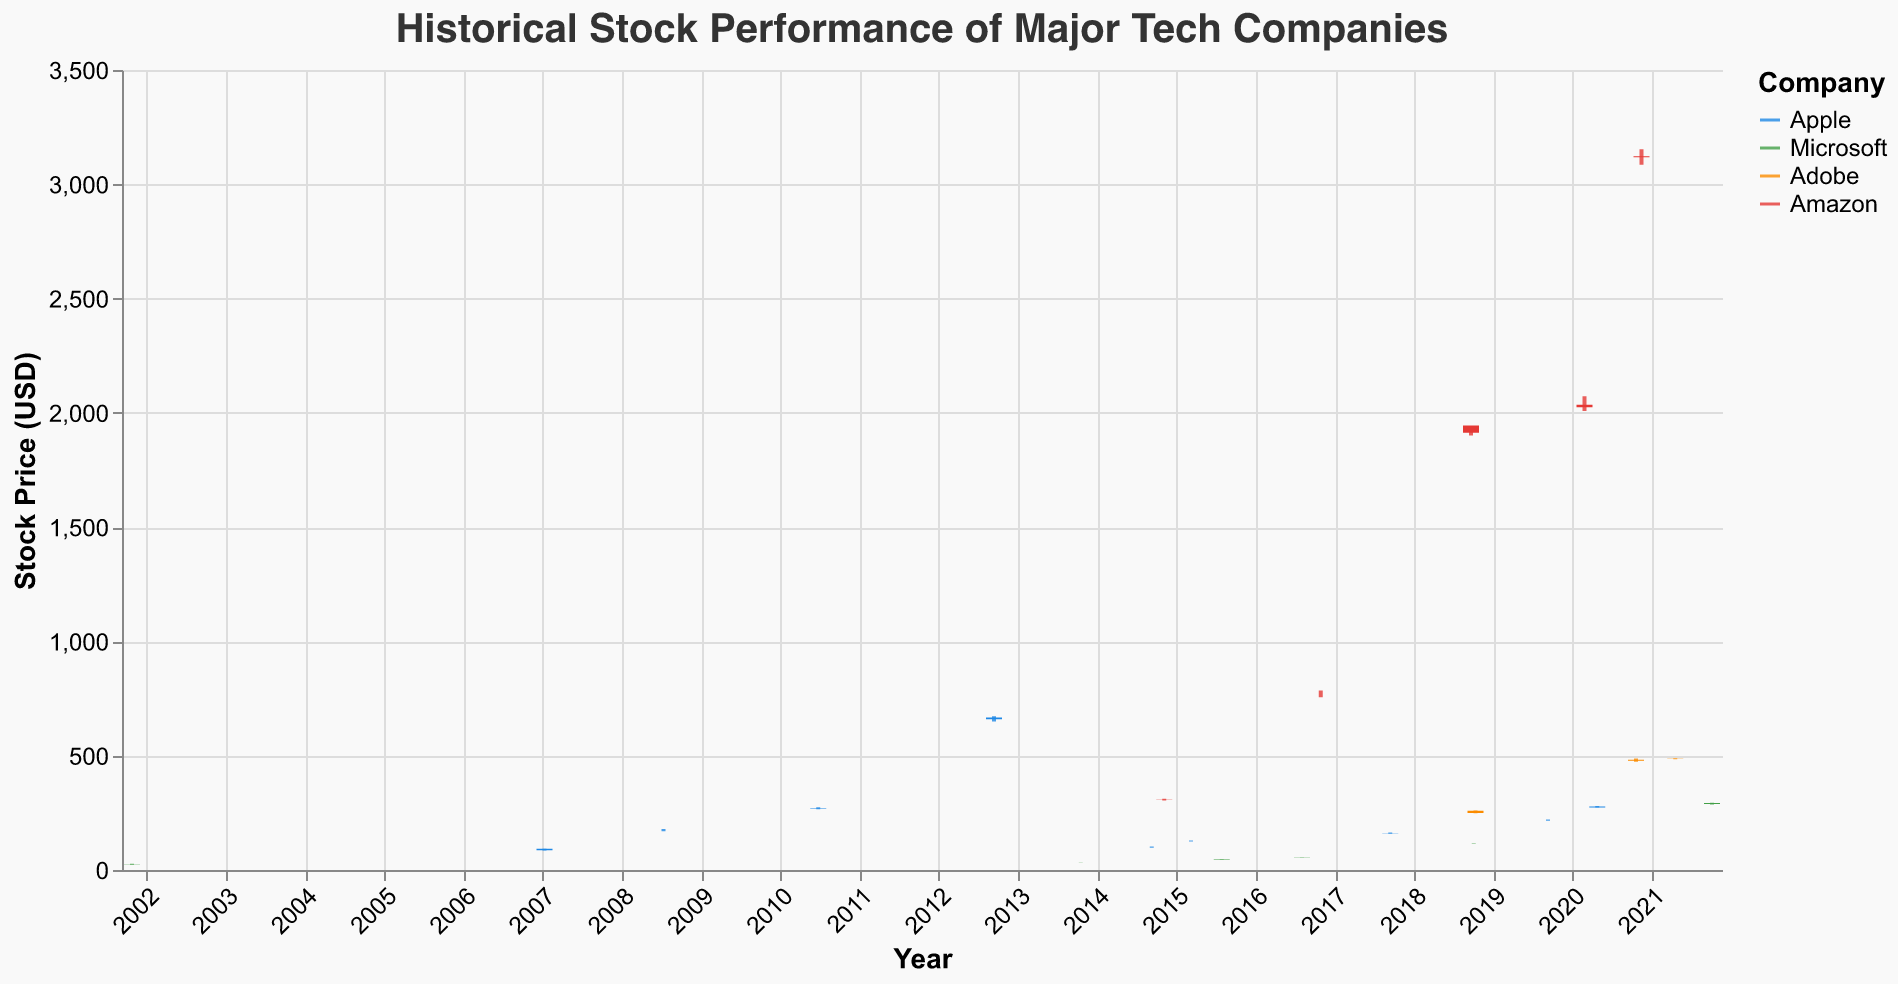How many companies are represented in the figure? The title of the figure and the legend indicate that the plot represents data from four companies: Apple, Microsoft, Adobe, and Amazon.
Answer: 4 What is the stock price range for Apple on 2012-09-12? On 2012-09-12, Apple has a Low value of 650.0 and a High value of 673.0 as visible in the candlestick plot.
Answer: 650.0 - 673.0 Which company had the highest closing price according to the plot? By examining the y-axis values of the closing prices for all companies, Amazon had the highest closing price on 2020-11-14, which was 3118.06.
Answer: Amazon How does the stock price of Microsoft on 2001-10-25 compare to its stock price on 2021-10-05? On 2001-10-25, Microsoft's closing price was 26.49, whereas on 2021-10-05, it was 292.8. The closing price increased significantly over the years.
Answer: Increased Which day had the lowest trading volume for Amazon? By looking at the volume values for Amazon, the lowest trading volume was 5,320,000 on 2018-09-20.
Answer: 2018-09-20 What was the percentage increase in Apple's closing price from 2007-01-09 to 2012-09-12? Apple's closing price on 2007-01-09 was 92.57 and on 2012-09-12 was 667.1. The percentage increase is calculated as ((667.1 - 92.57) / 92.57) * 100.
Answer: 620.9% Did Adobe's stock price rise or fall on 2020-10-20? On 2020-10-20, Adobe's opening price was 477.89 and its closing price was 481.87, indicating an increase in stock price that day.
Answer: Rise Which company had the highest trading volume on their respective dates? Comparing the volume values, Apple had the highest trading volume of 189,000,000 on 2014-09-09.
Answer: Apple 